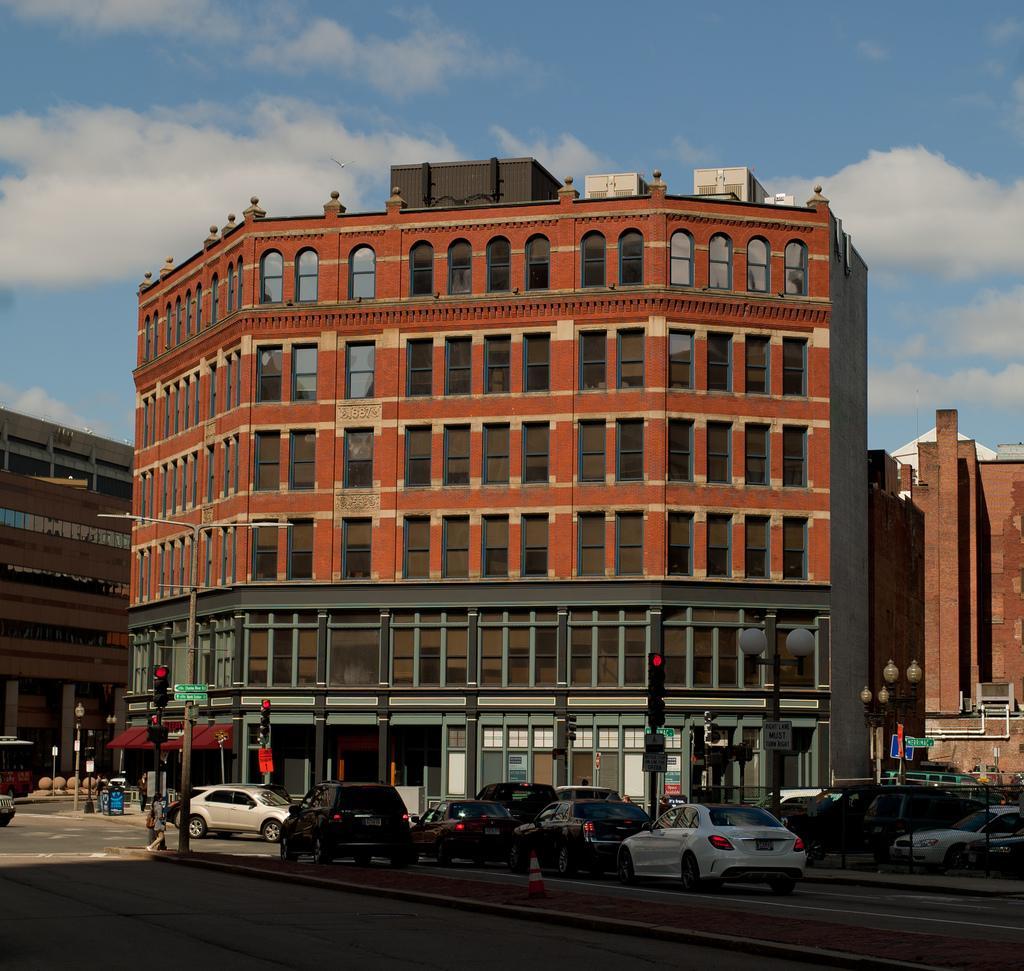Please provide a concise description of this image. In this image there is a road and vehicles are passing. There are people walking on the road. There are buildings. There are signal poles on the right and left side. There are clouds in the sky. 